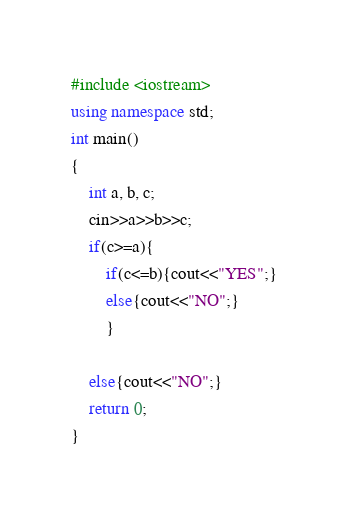Convert code to text. <code><loc_0><loc_0><loc_500><loc_500><_C++_>#include <iostream>
using namespace std;
int main()
{
	int a, b, c;
	cin>>a>>b>>c;
	if(c>=a){
		if(c<=b){cout<<"YES";}
		else{cout<<"NO";}
		}
	
	else{cout<<"NO";}
	return 0;
}</code> 